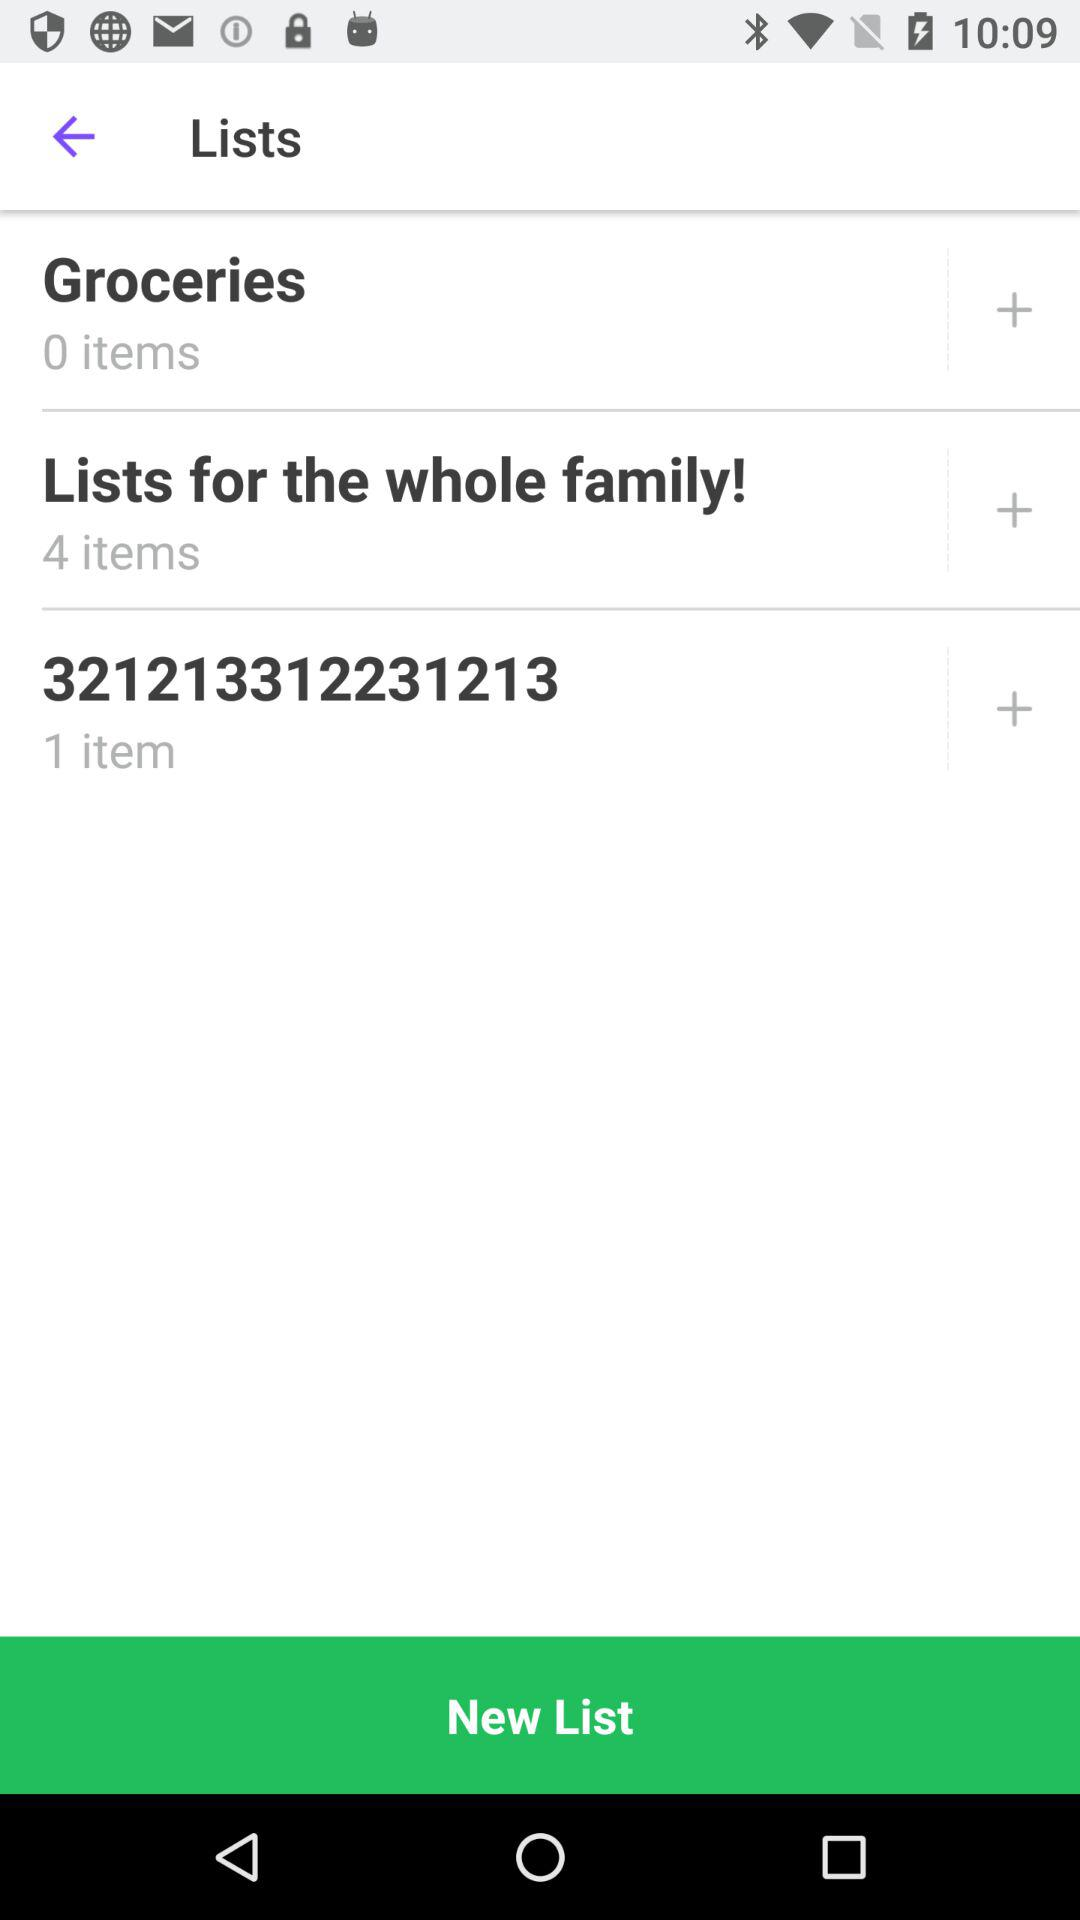What is the number of items in "321213312231213"? The number of items is 1. 